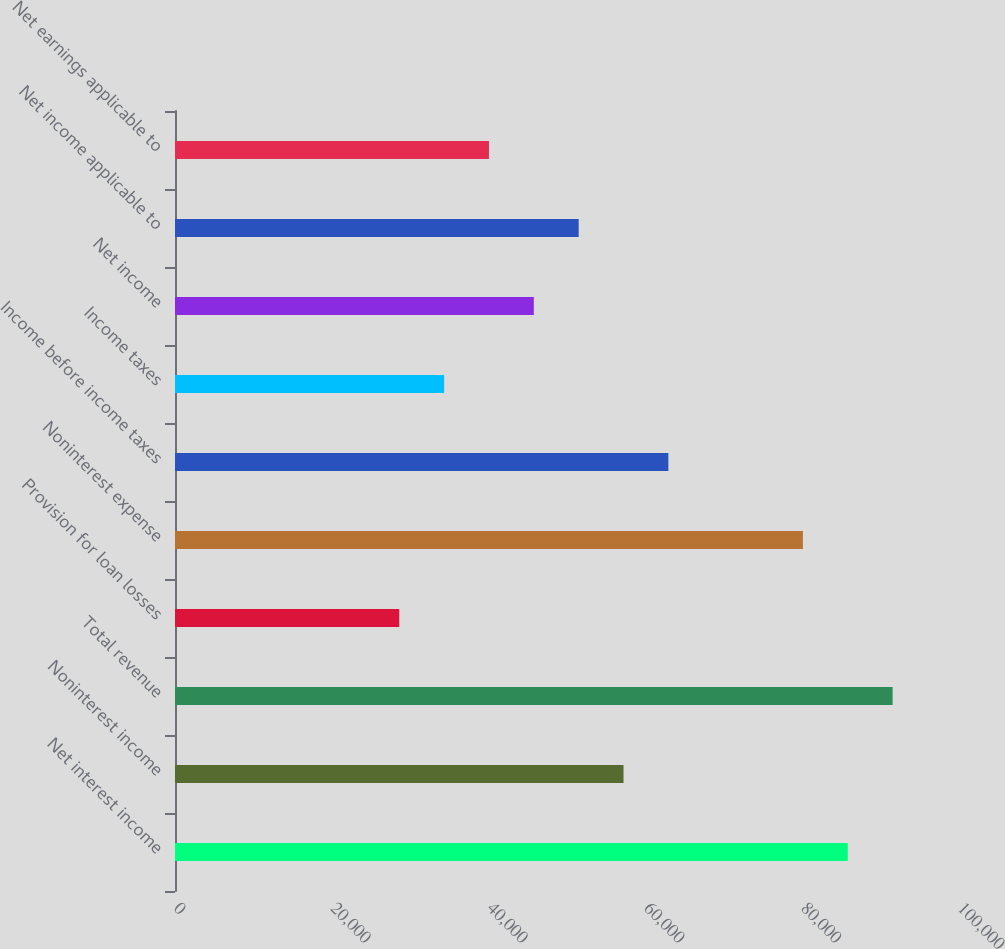Convert chart to OTSL. <chart><loc_0><loc_0><loc_500><loc_500><bar_chart><fcel>Net interest income<fcel>Noninterest income<fcel>Total revenue<fcel>Provision for loan losses<fcel>Noninterest expense<fcel>Income before income taxes<fcel>Income taxes<fcel>Net income<fcel>Net income applicable to<fcel>Net earnings applicable to<nl><fcel>85813.4<fcel>57209<fcel>91534.2<fcel>28604.6<fcel>80092.5<fcel>62929.8<fcel>34325.4<fcel>45767.2<fcel>51488.1<fcel>40046.3<nl></chart> 